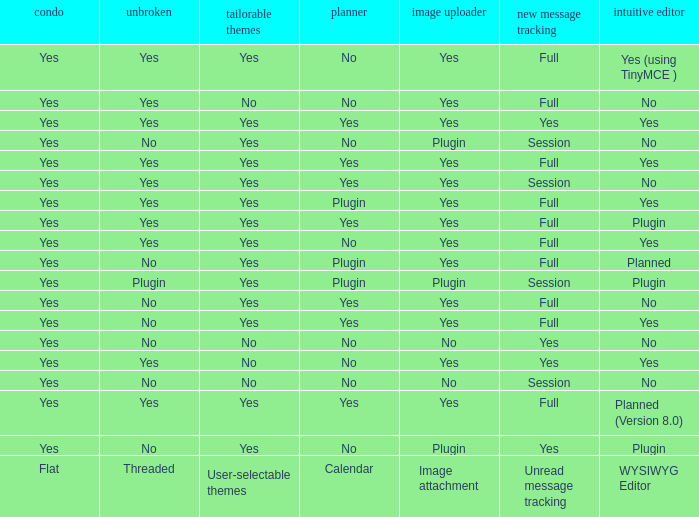Which WYSIWYG Editor has a User-selectable themes of yes, and an Unread message tracking of session, and an Image attachment of plugin? No, Plugin. 